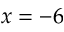<formula> <loc_0><loc_0><loc_500><loc_500>x = - 6</formula> 